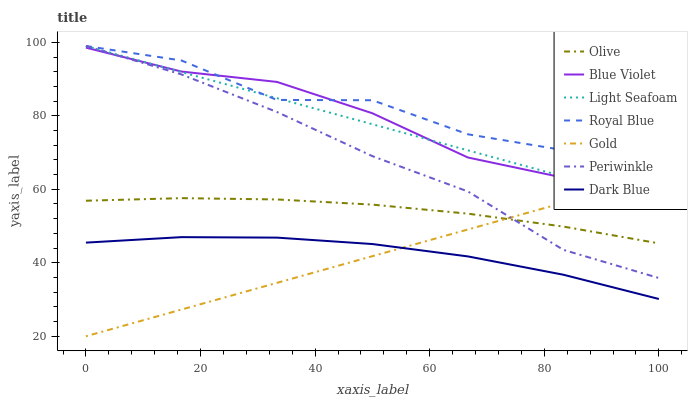Does Gold have the minimum area under the curve?
Answer yes or no. Yes. Does Royal Blue have the maximum area under the curve?
Answer yes or no. Yes. Does Dark Blue have the minimum area under the curve?
Answer yes or no. No. Does Dark Blue have the maximum area under the curve?
Answer yes or no. No. Is Gold the smoothest?
Answer yes or no. Yes. Is Royal Blue the roughest?
Answer yes or no. Yes. Is Dark Blue the smoothest?
Answer yes or no. No. Is Dark Blue the roughest?
Answer yes or no. No. Does Gold have the lowest value?
Answer yes or no. Yes. Does Dark Blue have the lowest value?
Answer yes or no. No. Does Light Seafoam have the highest value?
Answer yes or no. Yes. Does Dark Blue have the highest value?
Answer yes or no. No. Is Olive less than Light Seafoam?
Answer yes or no. Yes. Is Blue Violet greater than Olive?
Answer yes or no. Yes. Does Gold intersect Periwinkle?
Answer yes or no. Yes. Is Gold less than Periwinkle?
Answer yes or no. No. Is Gold greater than Periwinkle?
Answer yes or no. No. Does Olive intersect Light Seafoam?
Answer yes or no. No. 